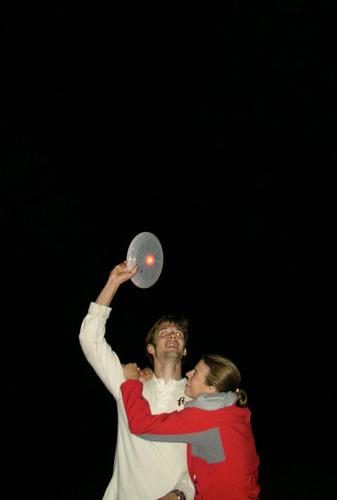What does the man appear to have caught?
Be succinct. Frisbee. Are they hugging?
Quick response, please. Yes. Why are the people hugging?
Be succinct. Playing. Do these people hate each other?
Concise answer only. No. 